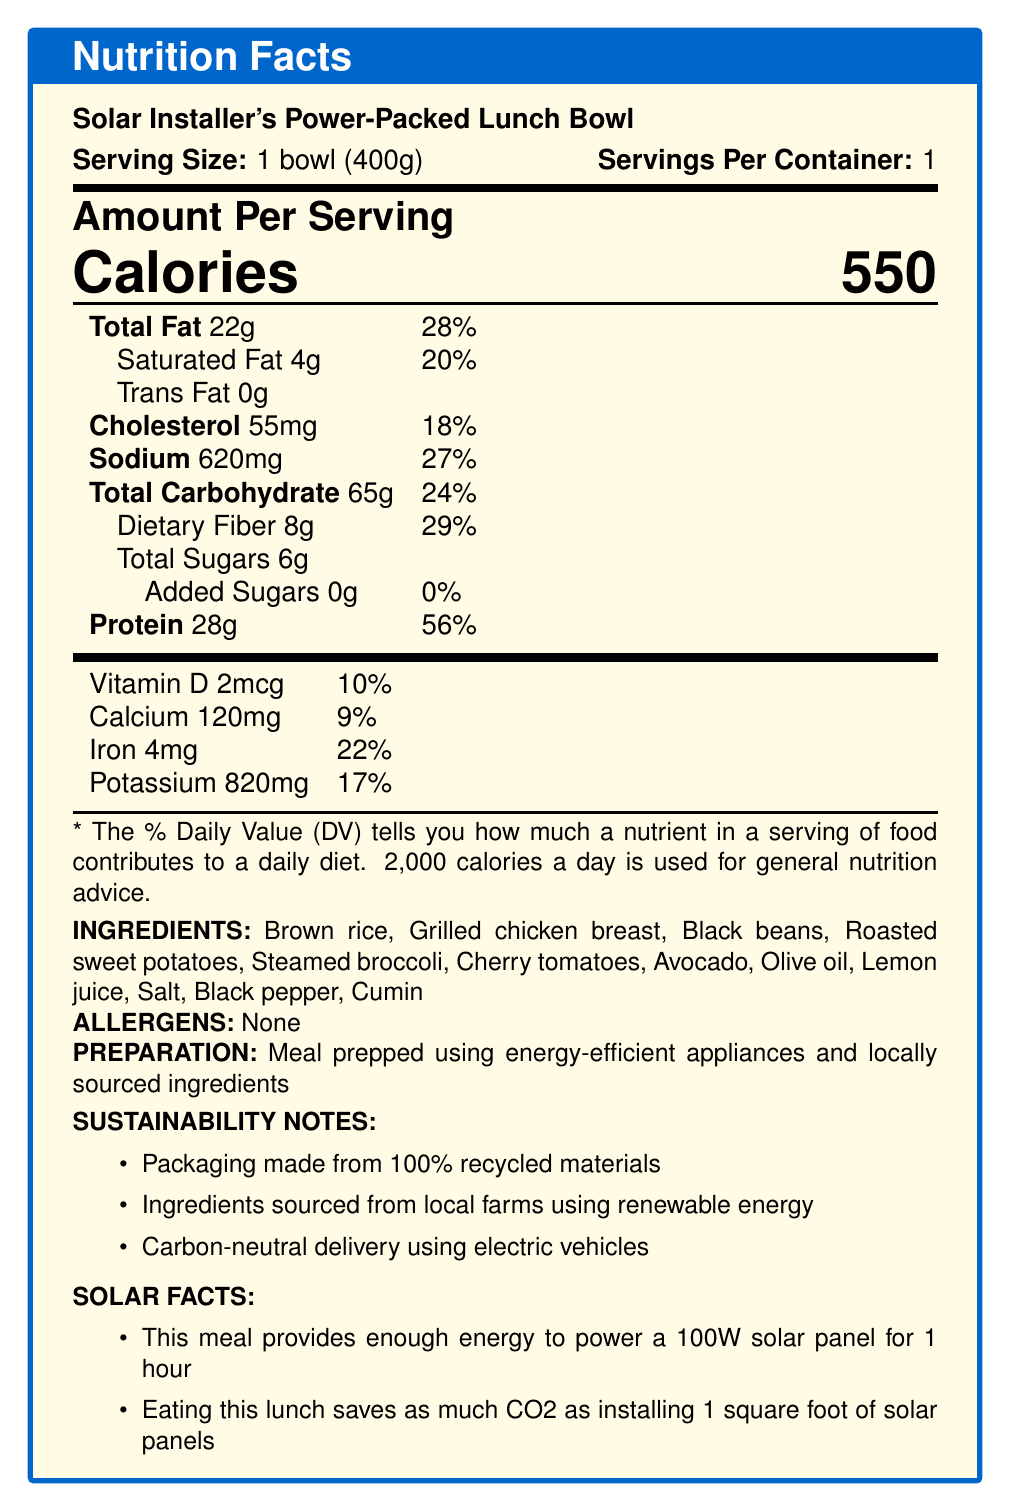what is the serving size? The label specifies that the serving size is 1 bowl, which weighs 400 grams.
Answer: 1 bowl (400g) how many calories are there per serving? The nutrition facts section explicitly states that the amount of calories per serving is 550.
Answer: 550 what is the amount of protein in the lunch bowl? The nutrition facts indicate that there are 28 grams of protein per serving.
Answer: 28g how much dietary fiber does the lunch bowl contain? According to the nutrition facts, the lunch bowl contains 8 grams of dietary fiber per serving.
Answer: 8g what is the percentage daily value of total fat? The nutrition facts say that total fat is 22 grams, which is 28% of the daily value.
Answer: 28% what ingredients are listed in the lunch bowl? The document lists all these ingredients under the "INGREDIENTS" section.
Answer: Brown rice, Grilled chicken breast, Black beans, Roasted sweet potatoes, Steamed broccoli, Cherry tomatoes, Avocado, Olive oil, Lemon juice, Salt, Black pepper, Cumin how many grams of saturated fat does the lunch bowl contain? The nutrition facts state that the lunch bowl contains 4 grams of saturated fat.
Answer: 4g the meal provides enough energy to power which device for 1 hour? Under the "SOLAR FACTS" section, it mentions that the meal provides enough energy to power a 100W solar panel for 1 hour.
Answer: a 100W solar panel how much iron is in one serving of the lunch bowl? The nutrition facts detail that there are 4 milligrams of iron in a serving.
Answer: 4mg what is the main idea of the document? The entire document focuses on the nutritional information of the meal and also highlights sustainability and solar energy aspects.
Answer: The document provides nutrition facts for the Solar Installer's Power-Packed Lunch Bowl, including calorie and nutrient breakdown, ingredients, allergens, preparation methods, sustainability notes, and interesting solar energy-related facts. how much cholesterol does the lunch bowl contain? The nutrition facts list 55 milligrams of cholesterol per serving.
Answer: 55mg what percentage of the daily value does the dietary fiber content of the lunch bowl represent? The nutrition facts indicate that the dietary fiber content (8g) represents 29% of the daily value.
Answer: 29% which of the following is NOT an ingredient in the lunch bowl? A. Brown rice B. Turkey breast C. Black beans The listed ingredients include brown rice and black beans, but not turkey breast.
Answer: B. Turkey breast which preparation method is used for the lunch bowl? A. Prepped using traditional methods B. Prepped with energy-efficient appliances C. Prepped with energy-inefficient appliances D. Prepped using imported ingredients The document specifies that the meal is prepped using energy-efficient appliances and locally sourced ingredients.
Answer: B. Prepped with energy-efficient appliances is the packaging made from recycled materials? The "SUSTAINABILITY NOTES" section states that the packaging is made from 100% recycled materials.
Answer: Yes how much calcium is in a single serving of the lunch bowl? The nutrition facts indicate that there are 120 milligrams of calcium per serving.
Answer: 120mg what is the amount of potassium in one serving of the lunch bowl? The nutrition facts state that there are 820 milligrams of potassium per serving.
Answer: 820mg what is the daily value percentage for added sugars? The nutrition facts reveal that the added sugars amount is 0 grams, which corresponds to 0% of the daily value.
Answer: 0% what is the total carbohydrate content in the meal? According to the nutrition facts, the total carbohydrate content is 65 grams per serving.
Answer: 65g how is the meal delivered in a sustainable manner? The sustainability notes indicate that the meal is delivered in a carbon-neutral manner using electric vehicles.
Answer: Carbon-neutral delivery using electric vehicles how much Vitamin D does the lunch bowl contain? The nutrition facts indicate that the lunch bowl contains 2 micrograms of Vitamin D.
Answer: 2mcg how many calories would two servings of the lunch bowl provide? The document specifies values for one serving, but it does not directly state the values for multiple servings.
Answer: Cannot be determined what is the daily value percentage of sodium in the lunch bowl? According to the nutrition facts, the sodium content is 620 milligrams, which is 27% of the daily value.
Answer: 27% 